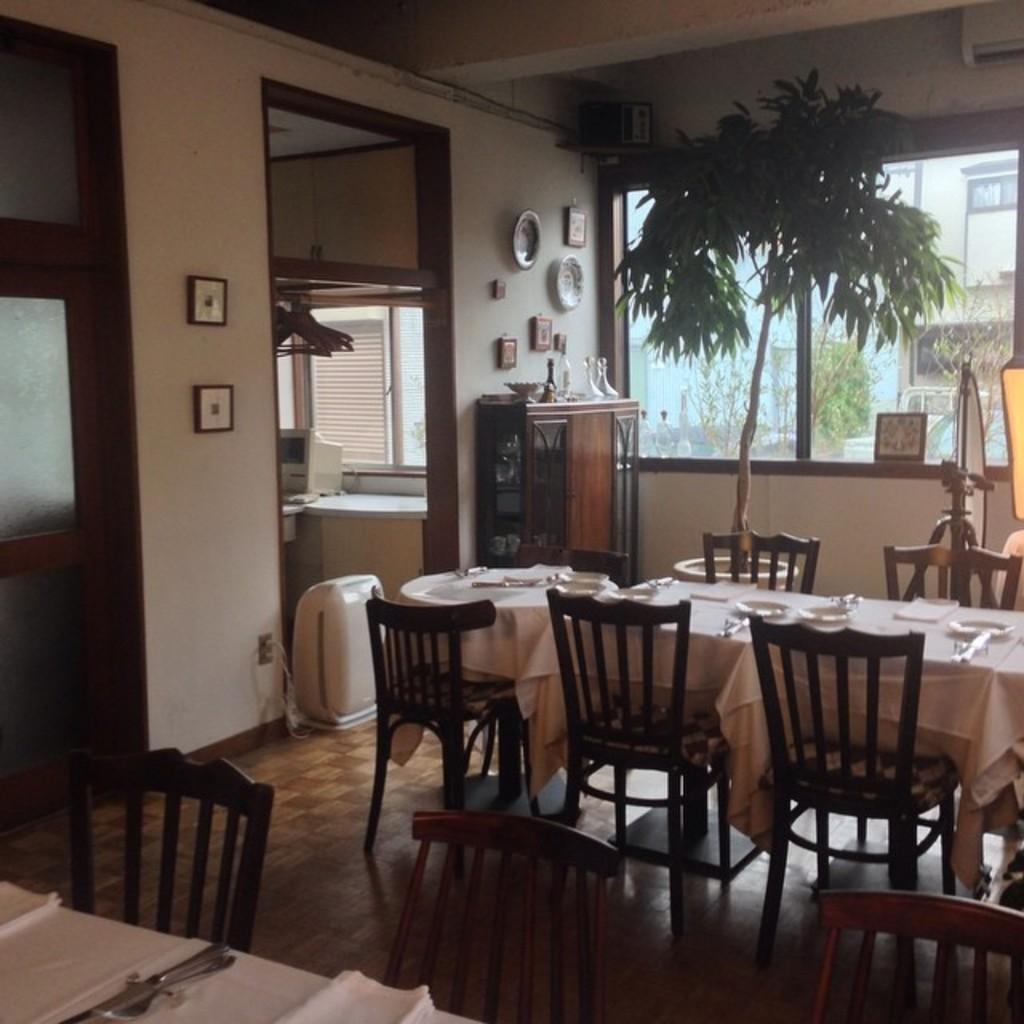How would you summarize this image in a sentence or two? In this image, there are some chairs. We can see some tables covered with white colored cloth and some objects on it. We can also see some trees. We can see the ground. We can see the wall with some objects. We can see a small wooden wardrobe with some objects. We can also see the window. 